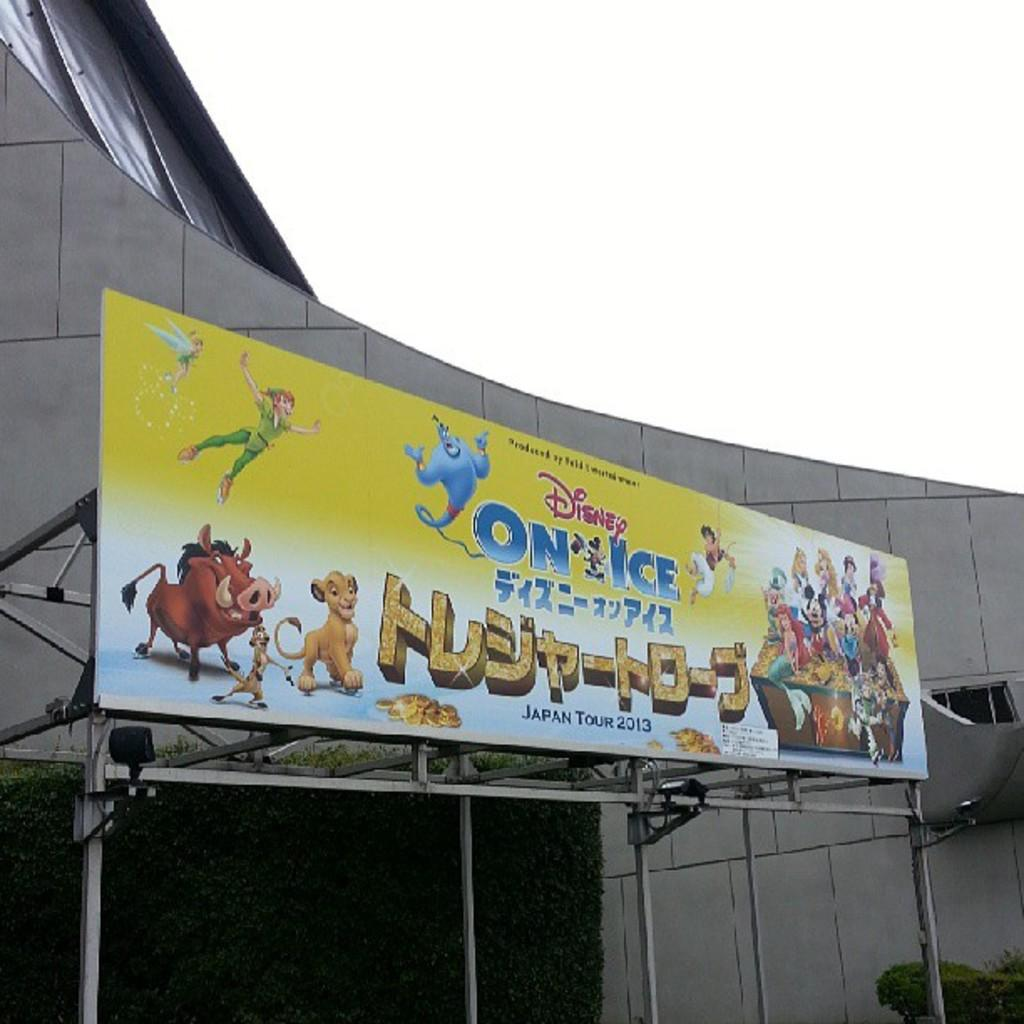What type of structure is visible in the image? There is a building in the image. What is located in front of the building? There is a hoarding with text in front of the building. What can be seen at the top of the image? The sky is visible at the top of the image. What is the price of the crate in the image? There is no crate present in the image, so it is not possible to determine its price. 